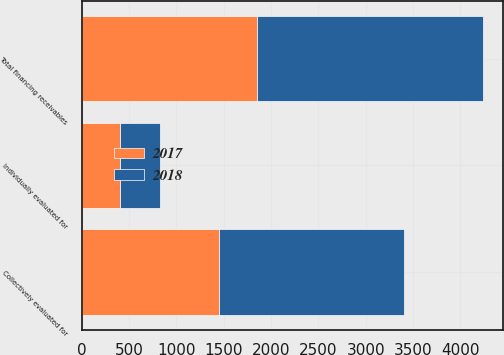Convert chart to OTSL. <chart><loc_0><loc_0><loc_500><loc_500><stacked_bar_chart><ecel><fcel>Individually evaluated for<fcel>Collectively evaluated for<fcel>Total financing receivables<nl><fcel>2017<fcel>409<fcel>1446<fcel>1855<nl><fcel>2018<fcel>422<fcel>1964<fcel>2386<nl></chart> 